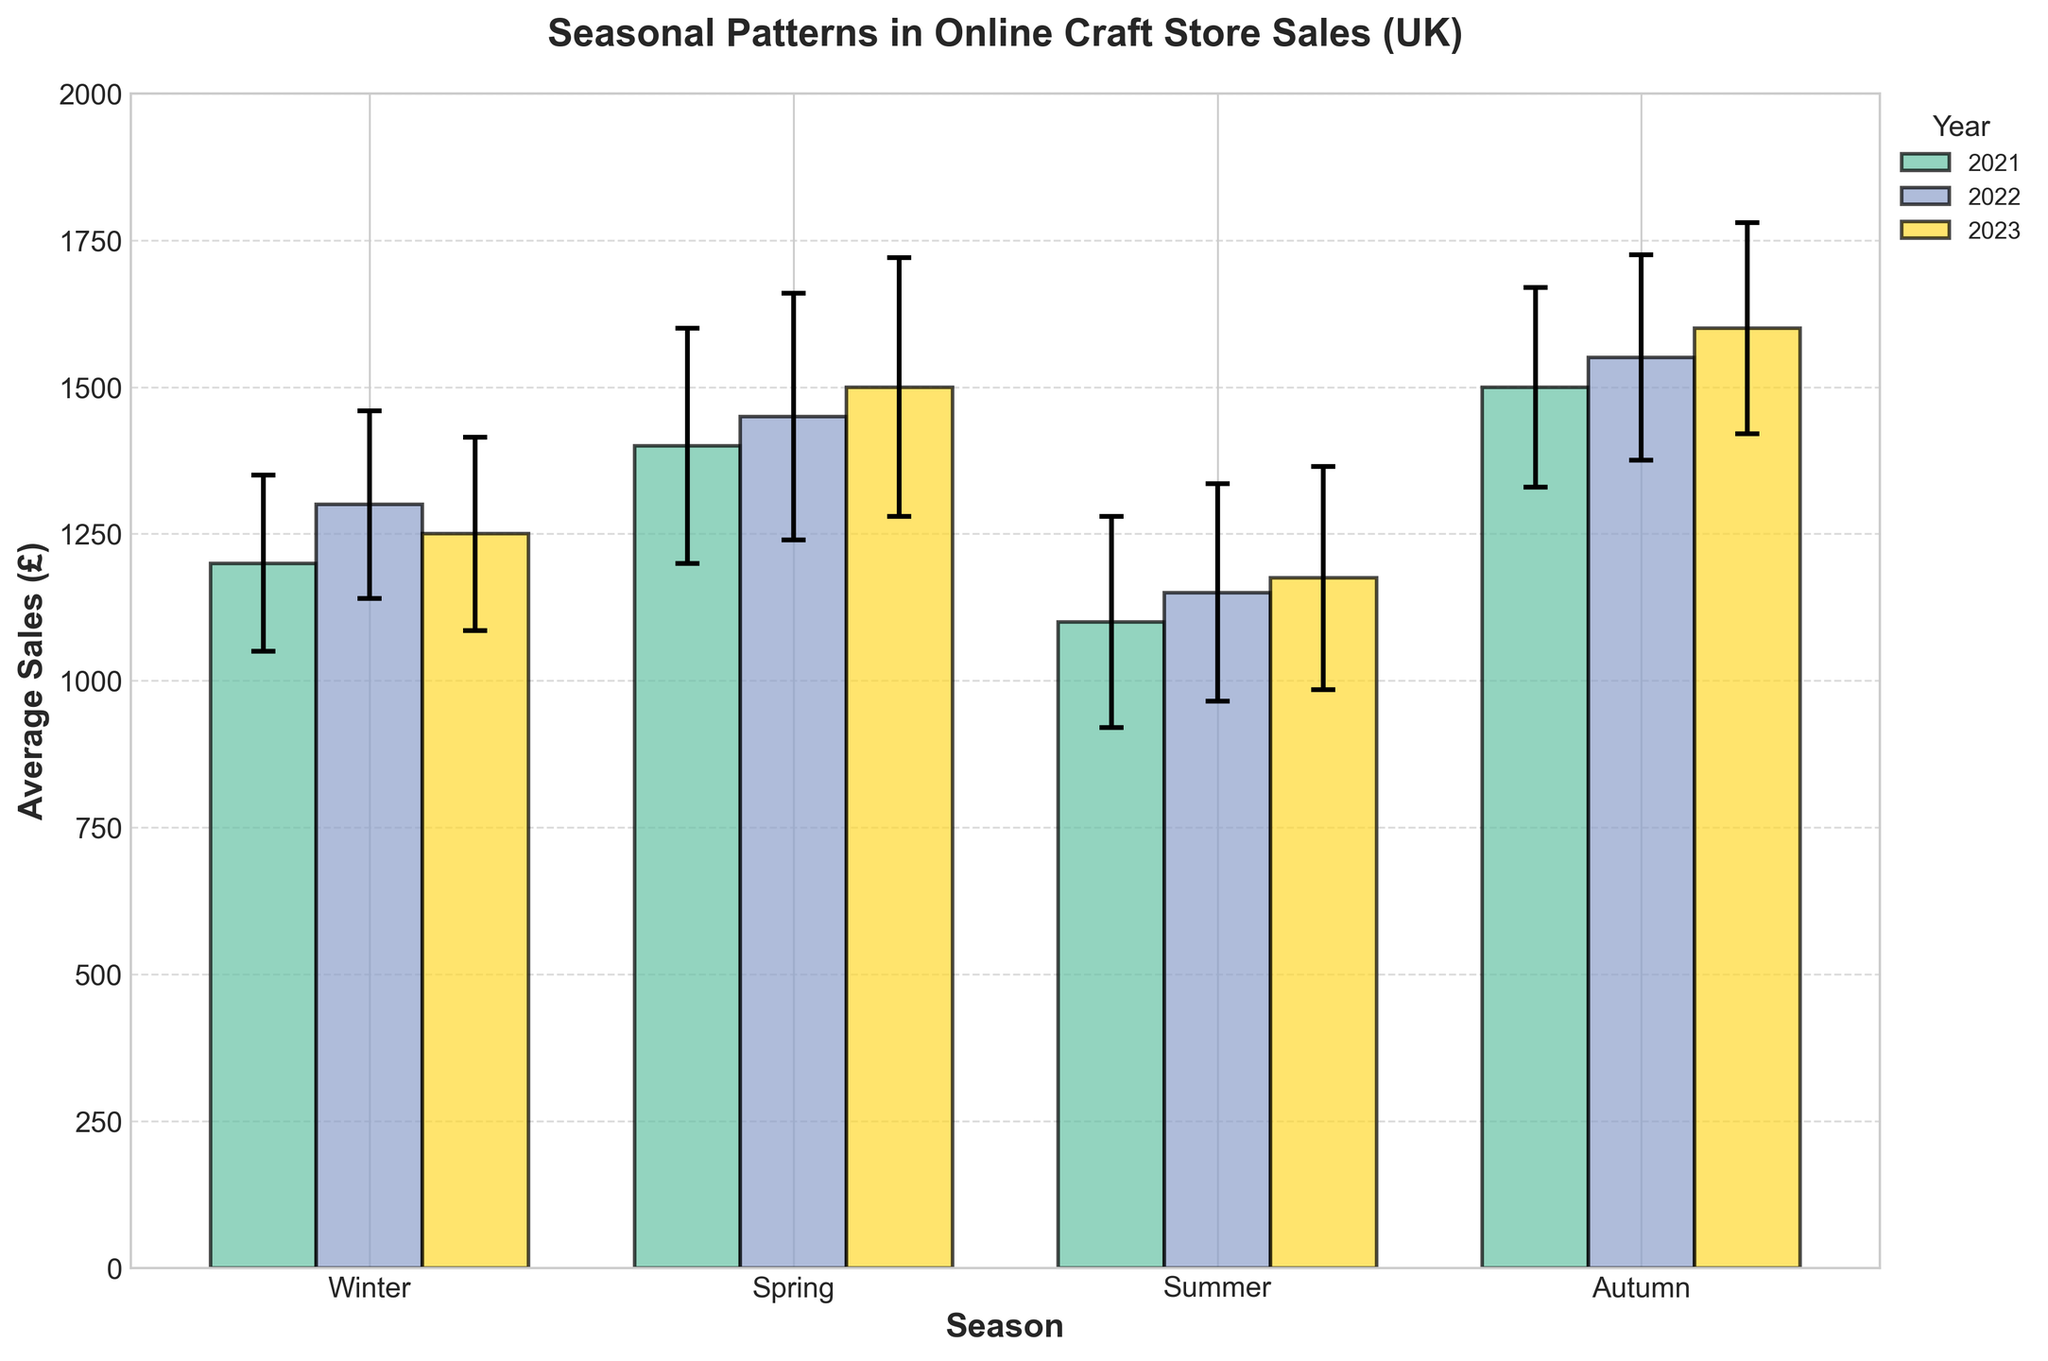What is the title of the figure? The title of the figure is typically found at the top of the chart. In this figure, it clearly states "Seasonal Patterns in Online Craft Store Sales (UK)."
Answer: Seasonal Patterns in Online Craft Store Sales (UK) During which season in 2021 were the sales the highest? To determine the highest sales in 2021, look for the tallest bar among the four seasons of that year, which is "Autumn."
Answer: Autumn What is the average sales for Winter 2023? Locate the bar corresponding to Winter 2023. The value written at the top or height of the bar represents the average sales, which is £1250.
Answer: £1250 How much did average sales increase from Winter 2021 to Winter 2022? Find the average sales for Winter 2021 (£1200) and Winter 2022 (£1300). Calculate the difference: 1300 - 1200 = 100.
Answer: £100 Which year had the highest average sales in Spring? Compare the Spring bars for 2021 (£1400), 2022 (£1450), and 2023 (£1500). The highest average sales are in Spring 2023.
Answer: 2023 Between which two consecutive seasons in 2022 is the largest drop in sales? Check the bars for consecutive seasons in 2022: 
- Winter (£1300) to Spring (£1450) = +150
- Spring (£1450) to Summer (£1150) = -300
- Summer (£1150) to Autumn (£1550) = +400.
The maximum drop is from Spring to Summer.
Answer: Spring to Summer What is the standard deviation for Summer 2022 and what does it signify? The standard deviation for Summer 2022 is denoted by the error bars on the figure and listed in the data, which is 185. This signifies the average amount sales vary from the mean during Summer 2022.
Answer: 185 In which year was the variation in sales (standard deviation) the highest for Autumn? Compare the error bars (standard deviation) for Autumn across 2021 (170), 2022 (175), and 2023 (180). The highest standard deviation is in 2023.
Answer: 2023 By how much do the average sales in Autumn 2023 exceed those in Summer 2023? Locate the bars for Autumn 2023 (£1600) and Summer 2023 (£1175). Calculate the difference: 1600 - 1175 = 425.
Answer: £425 